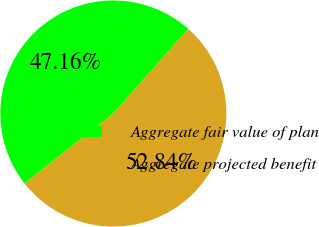Convert chart. <chart><loc_0><loc_0><loc_500><loc_500><pie_chart><fcel>Aggregate fair value of plan<fcel>Aggregate projected benefit<nl><fcel>47.16%<fcel>52.84%<nl></chart> 